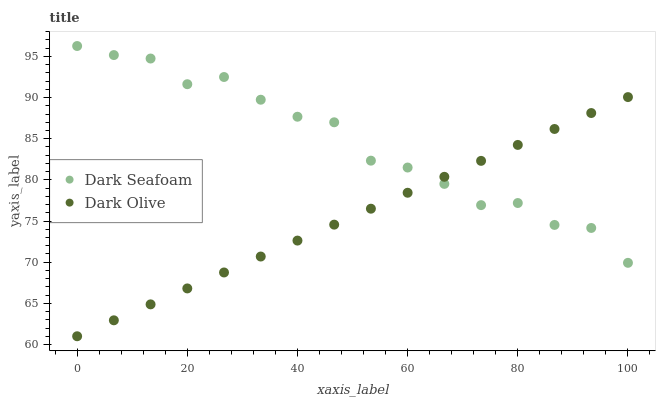Does Dark Olive have the minimum area under the curve?
Answer yes or no. Yes. Does Dark Seafoam have the maximum area under the curve?
Answer yes or no. Yes. Does Dark Olive have the maximum area under the curve?
Answer yes or no. No. Is Dark Olive the smoothest?
Answer yes or no. Yes. Is Dark Seafoam the roughest?
Answer yes or no. Yes. Is Dark Olive the roughest?
Answer yes or no. No. Does Dark Olive have the lowest value?
Answer yes or no. Yes. Does Dark Seafoam have the highest value?
Answer yes or no. Yes. Does Dark Olive have the highest value?
Answer yes or no. No. Does Dark Olive intersect Dark Seafoam?
Answer yes or no. Yes. Is Dark Olive less than Dark Seafoam?
Answer yes or no. No. Is Dark Olive greater than Dark Seafoam?
Answer yes or no. No. 